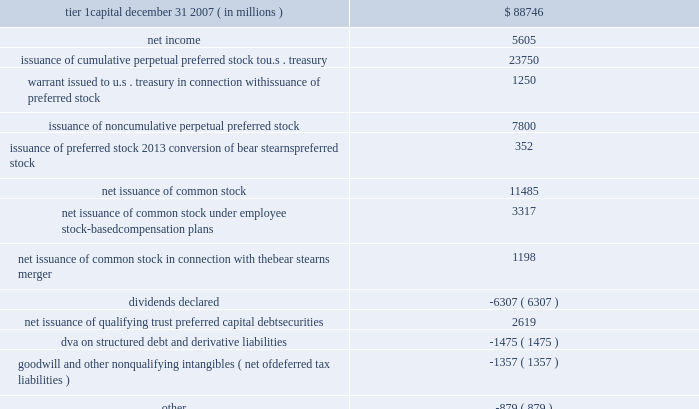Management 2019s discussion and analysis 84 jpmorgan chase & co .
/ 2008 annual report tier 1 capital was $ 136.1 billion at december 31 , 2008 , compared with $ 88.7 billion at december 31 , 2007 , an increase of $ 47.4 billion .
The table presents the changes in tier 1 capital for the year ended december 31 , 2008. .
Additional information regarding the firm 2019s capital ratios and the federal regulatory capital standards to which it is subject , and the capital ratios for the firm 2019s significant banking subsidiaries at december 31 , 2008 and 2007 , are presented in note 30 on pages 212 2013213 of this annual report .
Capital purchase program pursuant to the capital purchase program , on october 28 , 2008 , the firm issued to the u.s .
Treasury , for total proceeds of $ 25.0 billion , ( i ) 2.5 million shares of series k preferred stock , and ( ii ) a warrant to pur- chase up to 88401697 shares of the firm 2019s common stock , at an exer- cise price of $ 42.42 per share , subject to certain antidilution and other adjustments .
The series k preferred stock qualifies as tier 1 capital .
The series k preferred stock bears cumulative dividends at a rate of 5% ( 5 % ) per year for the first five years and 9% ( 9 % ) per year thereafter .
The series k preferred stock ranks equally with the firm 2019s existing 6.15% ( 6.15 % ) cumulative preferred stock , series e ; 5.72% ( 5.72 % ) cumulative preferred stock , series f ; 5.49% ( 5.49 % ) cumulative preferred stock , series g ; fixed- to-floating rate noncumulative perpetual preferred stock , series i ; and 8.63% ( 8.63 % ) noncumulative perpetual preferred stock , series j , in terms of dividend payments and upon liquidation of the firm .
Any accrued and unpaid dividends on the series k preferred stock must be fully paid before dividends may be declared or paid on stock ranking junior or equally with the series k preferred stock .
Pursuant to the capital purchase program , until october 28 , 2011 , the u.s .
Treasury 2019s consent is required for any increase in dividends on the firm 2019s common stock from the amount of the last quarterly stock div- idend declared by the firm prior to october 14 , 2008 , unless the series k preferred stock is redeemed in whole before then , or the u.s .
Treasury has transferred all of the series k preferred stock it owns to third parties .
The firm may not repurchase or redeem any common stock or other equity securities of the firm , or any trust preferred securities issued by the firm or any of its affiliates , without the prior consent of the u.s .
Treasury ( other than ( i ) repurchases of the series k preferred stock and ( ii ) repurchases of junior preferred shares or common stock in connection with any employee benefit plan in the ordinary course of business consistent with past practice ) .
Basel ii the minimum risk-based capital requirements adopted by the u.s .
Federal banking agencies follow the capital accord of the basel committee on banking supervision .
In 2004 , the basel committee published a revision to the accord ( 201cbasel ii 201d ) .
The goal of the new basel ii framework is to provide more risk-sensitive regulatory capital calculations and promote enhanced risk management practices among large , internationally active banking organizations .
U.s .
Bank- ing regulators published a final basel ii rule in december 2007 , which will require jpmorgan chase to implement basel ii at the holding company level , as well as at certain of its key u.s .
Bank subsidiaries .
Prior to full implementation of the new basel ii framework , jpmorgan chase will be required to complete a qualification period of four consecutive quarters during which it will need to demonstrate that it meets the requirements of the new rule to the satisfaction of its primary u.s .
Banking regulators .
The u.s .
Implementation timetable consists of the qualification period , starting any time between april 1 , 2008 , and april 1 , 2010 , followed by a minimum transition period of three years .
During the transition period , basel ii risk-based capital requirements cannot fall below certain floors based on current ( 201cbasel l 201d ) regulations .
Jpmorgan chase expects to be in compliance with all relevant basel ii rules within the estab- lished timelines .
In addition , the firm has adopted , and will continue to adopt , based upon various established timelines , basel ii in certain non-u.s .
Jurisdictions , as required .
Broker-dealer regulatory capital jpmorgan chase 2019s principal u.s .
Broker-dealer subsidiaries are j.p .
Morgan securities inc .
( 201cjpmorgan securities 201d ) and j.p .
Morgan clearing corp .
( formerly known as bear stearns securities corp. ) .
Jpmorgan securities and j.p .
Morgan clearing corp .
Are each subject to rule 15c3-1 under the securities exchange act of 1934 ( 201cnet capital rule 201d ) .
Jpmorgan securities and j.p .
Morgan clearing corp .
Are also registered as futures commission merchants and subject to rule 1.17 under the commodity futures trading commission ( 201ccftc 201d ) .
Jpmorgan securities and j.p .
Morgan clearing corp .
Have elected to compute their minimum net capital requirements in accordance with the 201calternative net capital requirement 201d of the net capital rule .
At december 31 , 2008 , jpmorgan securities 2019 net capital , as defined by the net capital rule , of $ 7.2 billion exceeded the minimum require- ment by $ 6.6 billion .
In addition to its net capital requirements , jpmorgan securities is required to hold tentative net capital in excess jpmorgan chase & co .
/ 2008 annual report84 .
What percentage of the increase in tier 1 capital was due to issuance of cumulative perpetual preferred stock to u.s . treasury? 
Computations: (23750 / 47358)
Answer: 0.5015. 